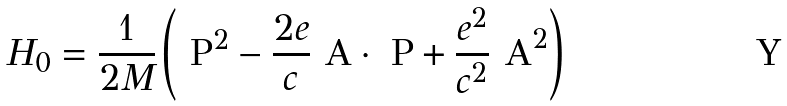Convert formula to latex. <formula><loc_0><loc_0><loc_500><loc_500>H _ { 0 } = \frac { 1 } { 2 M } \left ( \text { P} ^ { 2 } - \frac { 2 e } { c } \text { A} \cdot \text { P} + \frac { e ^ { 2 } } { c ^ { 2 } } \text { A} ^ { 2 } \right )</formula> 